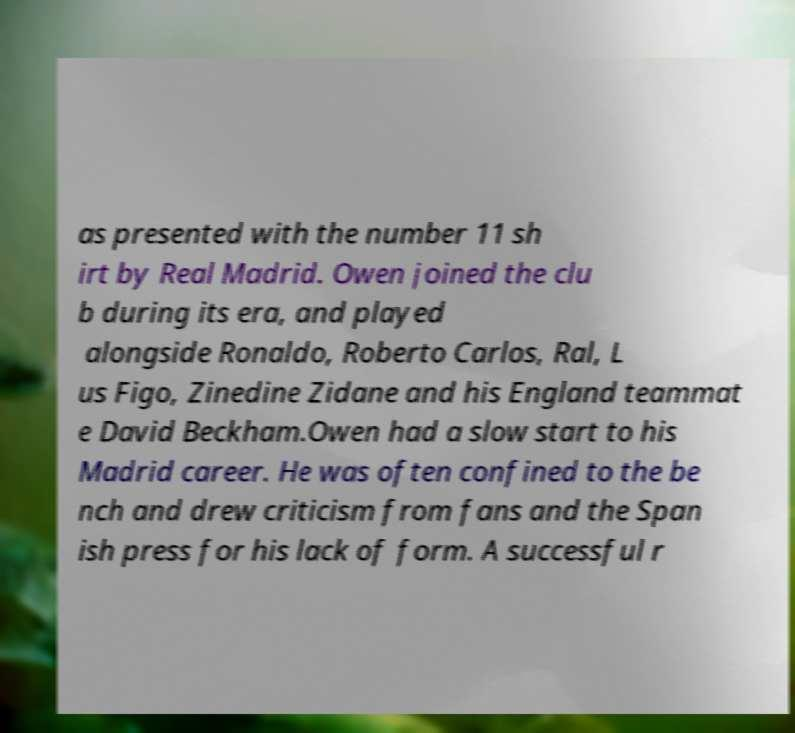Can you accurately transcribe the text from the provided image for me? as presented with the number 11 sh irt by Real Madrid. Owen joined the clu b during its era, and played alongside Ronaldo, Roberto Carlos, Ral, L us Figo, Zinedine Zidane and his England teammat e David Beckham.Owen had a slow start to his Madrid career. He was often confined to the be nch and drew criticism from fans and the Span ish press for his lack of form. A successful r 